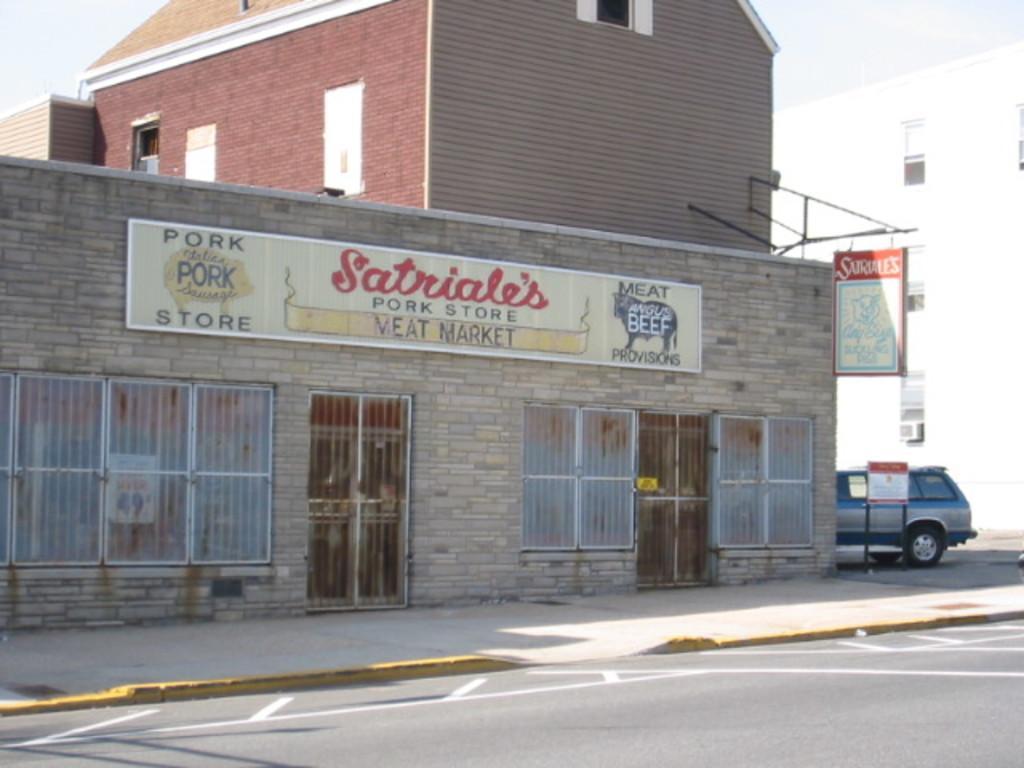Describe this image in one or two sentences. In this image we can see stone building, boards, a stone building, another building here and the sky in the background. 